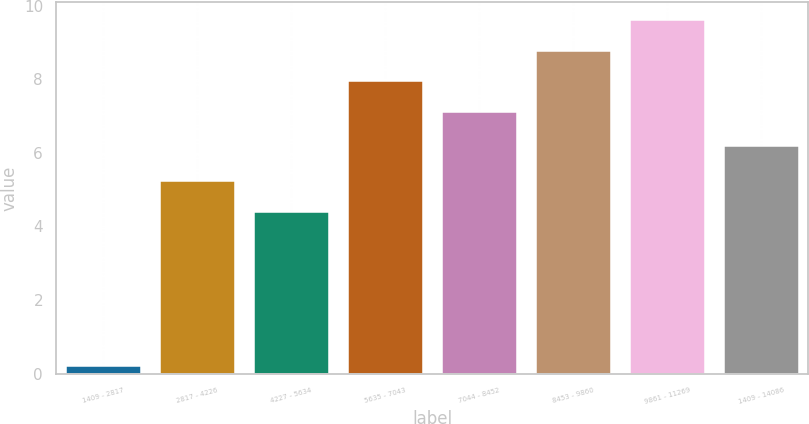Convert chart. <chart><loc_0><loc_0><loc_500><loc_500><bar_chart><fcel>1409 - 2817<fcel>2817 - 4226<fcel>4227 - 5634<fcel>5635 - 7043<fcel>7044 - 8452<fcel>8453 - 9860<fcel>9861 - 11269<fcel>1409 - 14086<nl><fcel>0.2<fcel>5.24<fcel>4.4<fcel>7.94<fcel>7.1<fcel>8.78<fcel>9.62<fcel>6.2<nl></chart> 